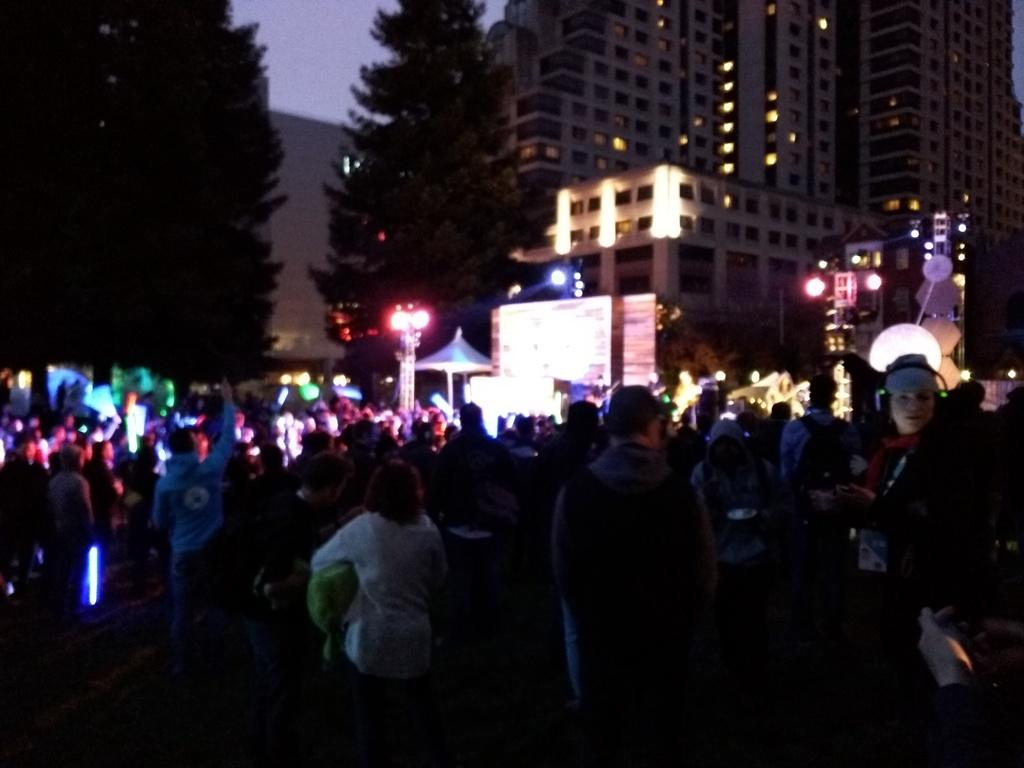What is happening in the image? There are people standing in the image. What can be seen in the background of the image? There are lights, trees, and buildings in the background of the image. How would you describe the lighting in the image? The image appears to be slightly dark. What type of pleasure can be seen flying with a wing in the image? There is no pleasure or wing present in the image; it features people standing and background elements. 